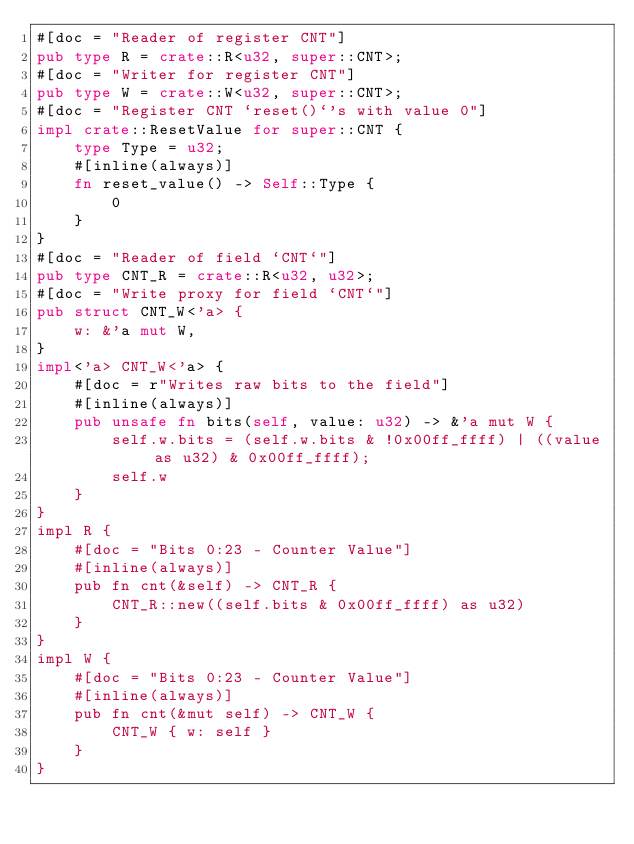<code> <loc_0><loc_0><loc_500><loc_500><_Rust_>#[doc = "Reader of register CNT"]
pub type R = crate::R<u32, super::CNT>;
#[doc = "Writer for register CNT"]
pub type W = crate::W<u32, super::CNT>;
#[doc = "Register CNT `reset()`'s with value 0"]
impl crate::ResetValue for super::CNT {
    type Type = u32;
    #[inline(always)]
    fn reset_value() -> Self::Type {
        0
    }
}
#[doc = "Reader of field `CNT`"]
pub type CNT_R = crate::R<u32, u32>;
#[doc = "Write proxy for field `CNT`"]
pub struct CNT_W<'a> {
    w: &'a mut W,
}
impl<'a> CNT_W<'a> {
    #[doc = r"Writes raw bits to the field"]
    #[inline(always)]
    pub unsafe fn bits(self, value: u32) -> &'a mut W {
        self.w.bits = (self.w.bits & !0x00ff_ffff) | ((value as u32) & 0x00ff_ffff);
        self.w
    }
}
impl R {
    #[doc = "Bits 0:23 - Counter Value"]
    #[inline(always)]
    pub fn cnt(&self) -> CNT_R {
        CNT_R::new((self.bits & 0x00ff_ffff) as u32)
    }
}
impl W {
    #[doc = "Bits 0:23 - Counter Value"]
    #[inline(always)]
    pub fn cnt(&mut self) -> CNT_W {
        CNT_W { w: self }
    }
}
</code> 